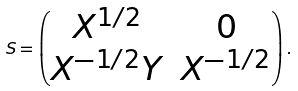Convert formula to latex. <formula><loc_0><loc_0><loc_500><loc_500>S = \begin{pmatrix} X ^ { 1 / 2 } & 0 \\ X ^ { - 1 / 2 } Y & X ^ { - 1 / 2 } \end{pmatrix} .</formula> 